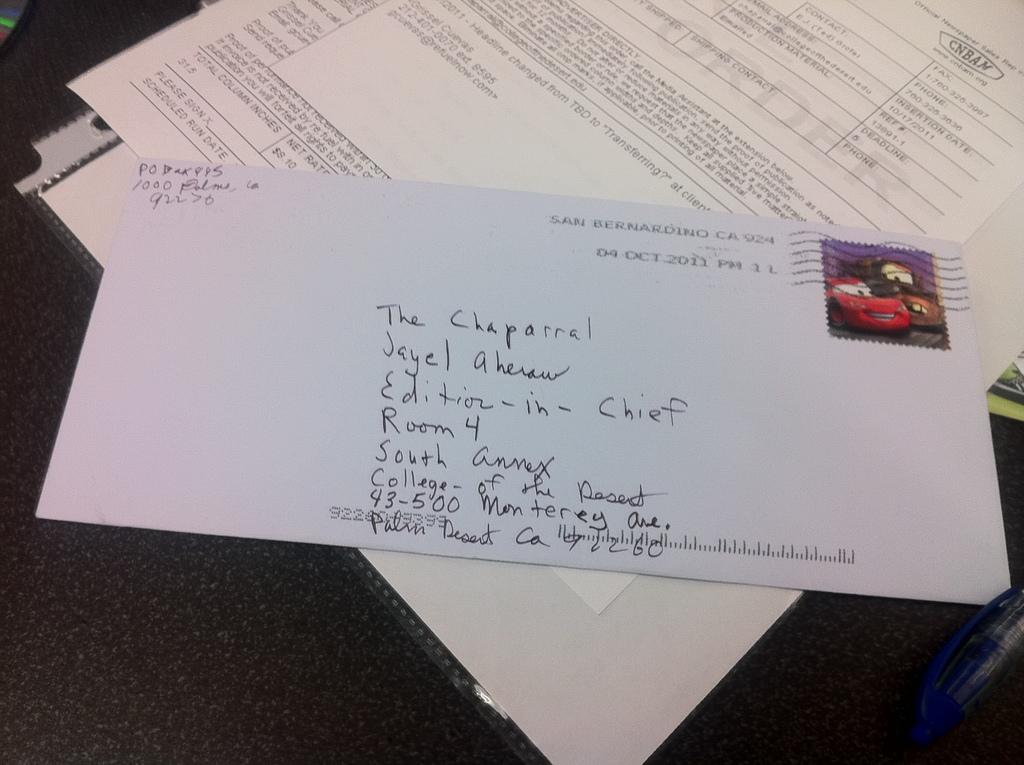<image>
Relay a brief, clear account of the picture shown. an envelope with hand written address for The Chaparral 